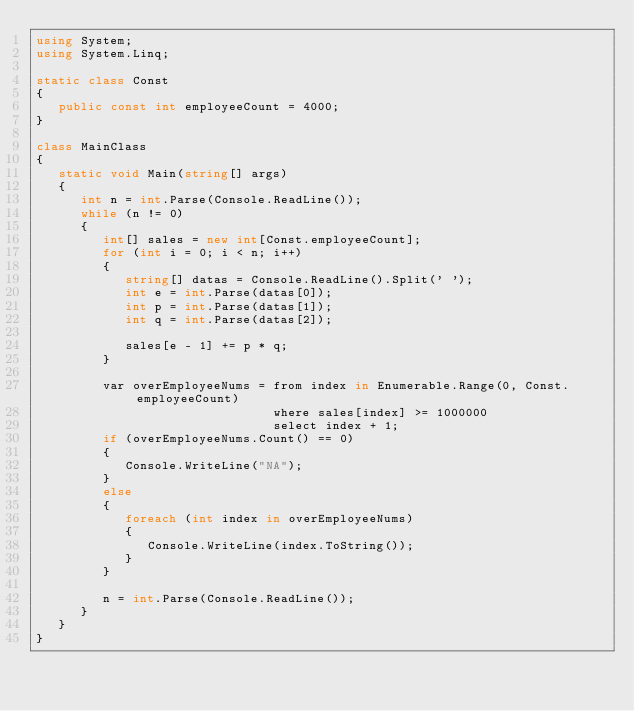Convert code to text. <code><loc_0><loc_0><loc_500><loc_500><_C#_>using System;
using System.Linq;

static class Const
{
   public const int employeeCount = 4000;
}

class MainClass
{
   static void Main(string[] args)
   {
      int n = int.Parse(Console.ReadLine());
      while (n != 0)
      {   
         int[] sales = new int[Const.employeeCount];
         for (int i = 0; i < n; i++)
         {
            string[] datas = Console.ReadLine().Split(' ');
            int e = int.Parse(datas[0]);
            int p = int.Parse(datas[1]);
            int q = int.Parse(datas[2]);

            sales[e - 1] += p * q;
         }

         var overEmployeeNums = from index in Enumerable.Range(0, Const.employeeCount)
                                where sales[index] >= 1000000
                                select index + 1;
         if (overEmployeeNums.Count() == 0)
         {
            Console.WriteLine("NA");
         }
         else 
         {
            foreach (int index in overEmployeeNums)
            {
               Console.WriteLine(index.ToString());
            }
         }

         n = int.Parse(Console.ReadLine());
      }
   }
}</code> 